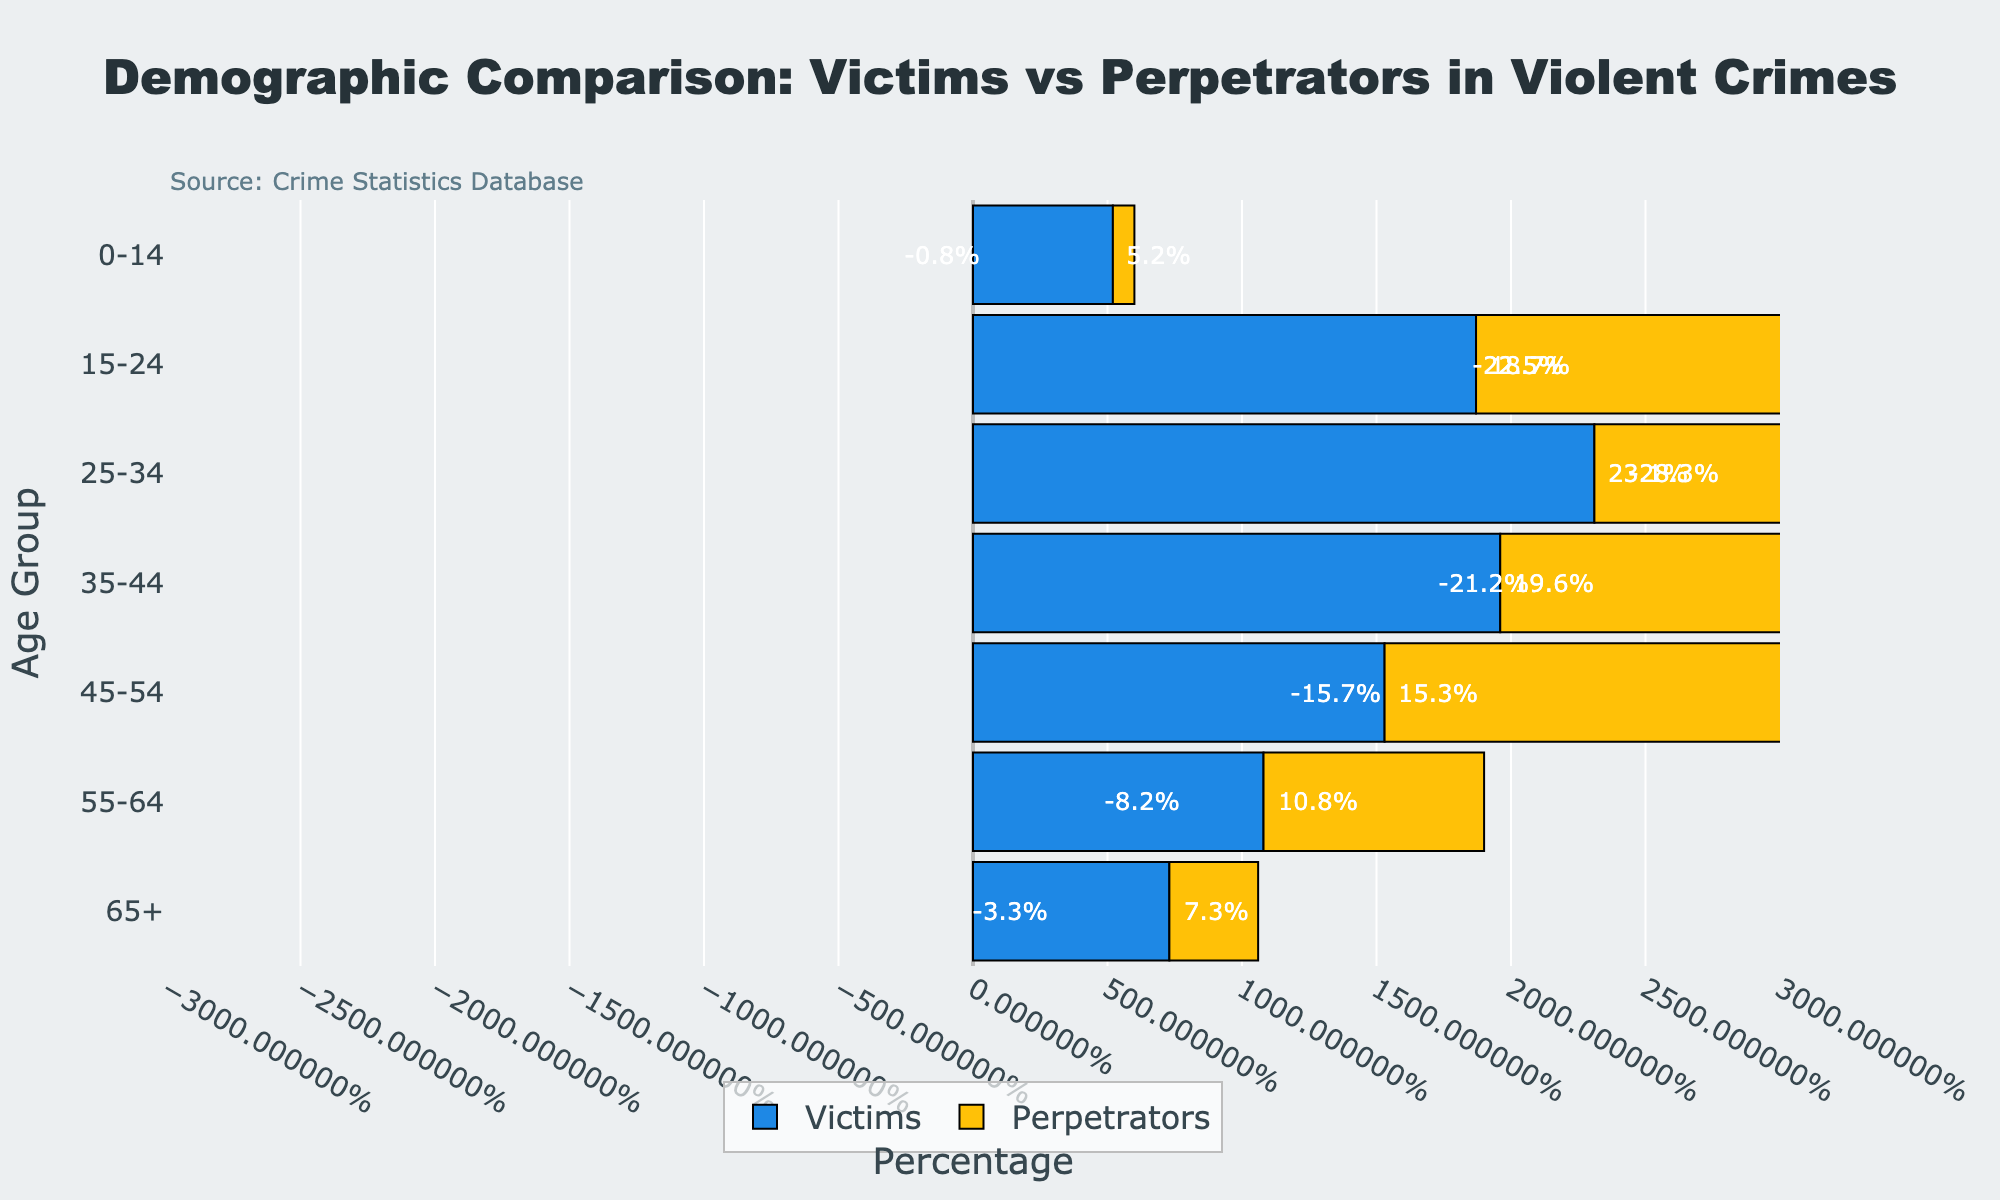What is the title of the figure? The title of the figure is displayed at the top center and reads, "Demographic Comparison: Victims vs Perpetrators in Violent Crimes."
Answer: Demographic Comparison: Victims vs Perpetrators in Violent Crimes Which age group has the highest percentage of victims? The bar representing the age group 25-34 extends the furthest to the right, indicating the highest percentage of victims at 23.1%.
Answer: 25-34 Which age group has the lowest percentage of perpetrators? The bar representing the age group 0-14 extends the least to the left, indicating the lowest percentage of perpetrators at 0.8%.
Answer: 0-14 What is the total percentage of victims in the age groups 55-64 and 65+? The percentage of victims in the age group 55-64 is 10.8%, and in the age group 65+ it is 7.3%. Summing these values gives 10.8 + 7.3 = 18.1%.
Answer: 18.1% What percentage difference is there between victims and perpetrators in the age group 15-24? The percentage of victims in the age group 15-24 is 18.7%, and the percentage of perpetrators is 22.5%. The difference is 22.5 - 18.7 = 3.8%.
Answer: 3.8% Which age group shows an equal percentage pattern for both victims and perpetrators? None of the age groups show an equal percentage pattern for victims and perpetrators; all have different percentages.
Answer: None Which age group among victims shows a notable decline in percentage compared to the next younger group? The age group 35-44 shows a notable decline in percentage of victims (19.6%) compared to the next younger group 25-34 (23.1%).
Answer: 35-44 What is the percentage difference between the highest and lowest groups of victims? The highest percentage among victims is for the 25-34 age group (23.1%), and the lowest is for the 0-14 age group (5.2%). The difference is 23.1 - 5.2 = 17.9%.
Answer: 17.9% How does the percentage of perpetrators in the 45-54 age group compare to that in the 55-64 age group? The percentage of perpetrators in the 45-54 age group is 15.7%, and in the 55-64 age group, it is 8.2%. The 45-54 age group has a higher percentage of perpetrators.
Answer: 45-54 has a higher percentage In which age group is the gap between victims and perpetrators most pronounced? The age group 25-34 shows the most pronounced gap, with 23.1% victims and 28.3% perpetrators, leading to a 5.2% difference.
Answer: 25-34 